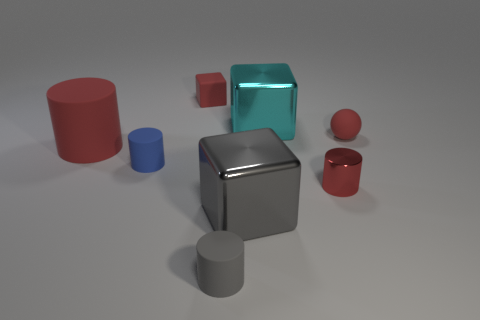There is a rubber cylinder that is the same size as the gray metallic cube; what is its color?
Offer a very short reply. Red. There is a shiny object behind the small red thing that is on the right side of the red metal object; what size is it?
Offer a terse response. Large. There is a sphere that is the same color as the shiny cylinder; what size is it?
Ensure brevity in your answer.  Small. How many other things are the same size as the red sphere?
Ensure brevity in your answer.  4. How many small brown matte blocks are there?
Your answer should be compact. 0. Does the gray cylinder have the same size as the gray cube?
Provide a succinct answer. No. What number of other things are there of the same shape as the gray metallic object?
Keep it short and to the point. 2. There is a cylinder in front of the block in front of the blue rubber thing; what is it made of?
Offer a very short reply. Rubber. Are there any large cubes in front of the tiny gray matte object?
Provide a succinct answer. No. Does the gray shiny object have the same size as the metallic block behind the big rubber cylinder?
Your response must be concise. Yes. 